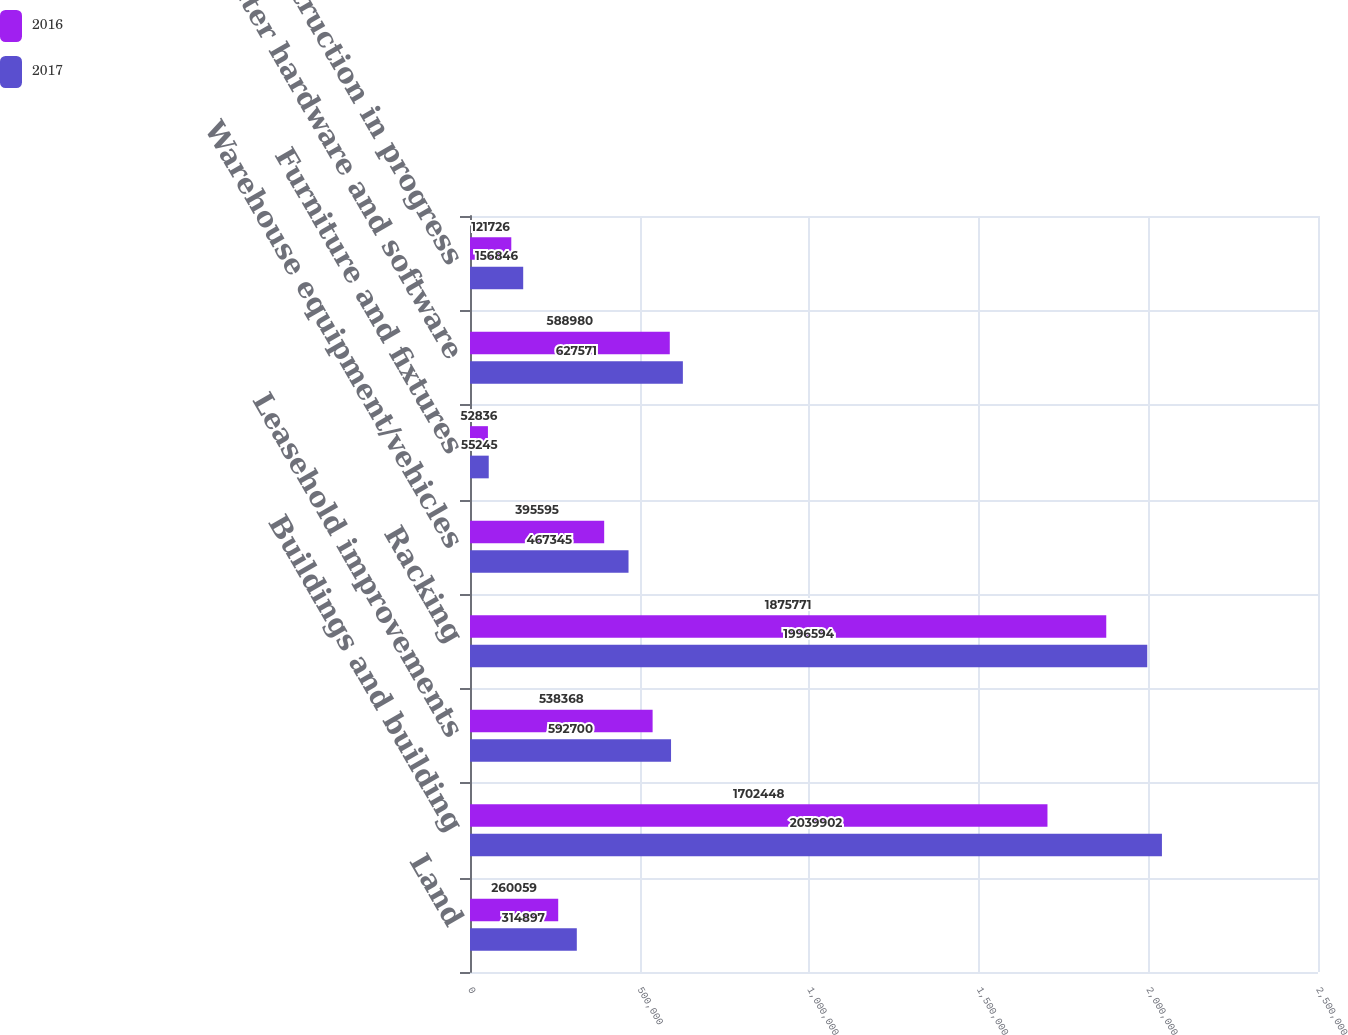Convert chart. <chart><loc_0><loc_0><loc_500><loc_500><stacked_bar_chart><ecel><fcel>Land<fcel>Buildings and building<fcel>Leasehold improvements<fcel>Racking<fcel>Warehouse equipment/vehicles<fcel>Furniture and fixtures<fcel>Computer hardware and software<fcel>Construction in progress<nl><fcel>2016<fcel>260059<fcel>1.70245e+06<fcel>538368<fcel>1.87577e+06<fcel>395595<fcel>52836<fcel>588980<fcel>121726<nl><fcel>2017<fcel>314897<fcel>2.0399e+06<fcel>592700<fcel>1.99659e+06<fcel>467345<fcel>55245<fcel>627571<fcel>156846<nl></chart> 